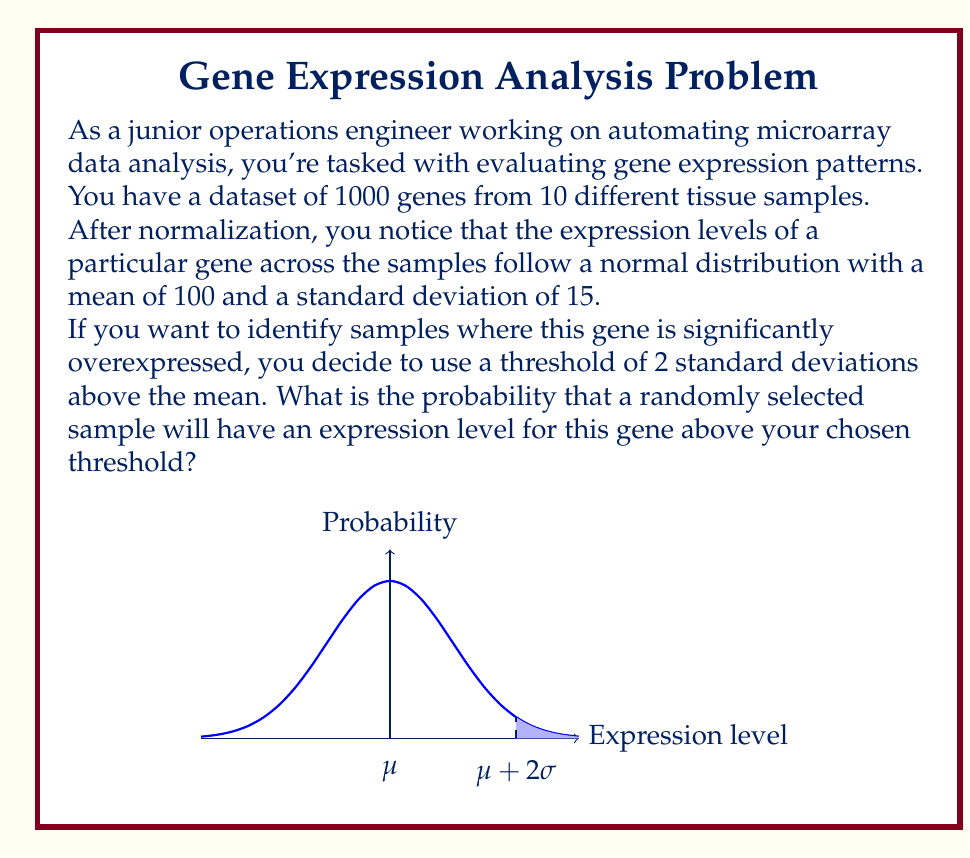Give your solution to this math problem. Let's approach this step-by-step:

1) We're dealing with a normal distribution where:
   $\mu = 100$ (mean)
   $\sigma = 15$ (standard deviation)

2) The threshold is set at 2 standard deviations above the mean:
   Threshold = $\mu + 2\sigma = 100 + 2(15) = 130$

3) To find the probability of a sample being above this threshold, we need to calculate the z-score for this value:

   $z = \frac{x - \mu}{\sigma} = \frac{130 - 100}{15} = 2$

4) The z-score of 2 corresponds to the threshold we set.

5) In a standard normal distribution, the area above z = 2 represents the probability we're looking for.

6) Using a standard normal distribution table or calculator, we can find that the area above z = 2 is approximately 0.0228.

7) This means that about 2.28% of the samples are expected to have an expression level above the threshold.

8) To convert to a probability, we divide by 100:
   0.0228 = 0.0228

Therefore, the probability that a randomly selected sample will have an expression level for this gene above the chosen threshold is approximately 0.0228 or 2.28%.
Answer: 0.0228 